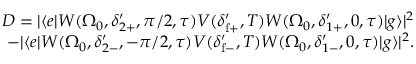<formula> <loc_0><loc_0><loc_500><loc_500>\begin{array} { r } { D = | \langle e | W ( \Omega _ { 0 } , \delta _ { 2 + } ^ { \prime } , \pi / 2 , \tau ) V ( \delta _ { f + } ^ { \prime } , T ) W ( \Omega _ { 0 } , \delta _ { 1 + } ^ { \prime } , 0 , \tau ) | g \rangle | ^ { 2 } } \\ { - | \langle e | W ( \Omega _ { 0 } , \delta _ { 2 - } ^ { \prime } , - \pi / 2 , \tau ) V ( \delta _ { f - } ^ { \prime } , T ) W ( \Omega _ { 0 } , \delta _ { 1 - } ^ { \prime } , 0 , \tau ) | g \rangle | ^ { 2 } . } \end{array}</formula> 